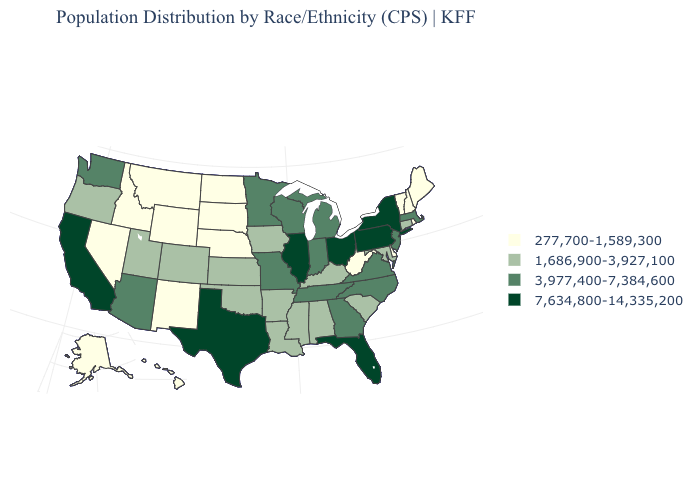What is the value of New Jersey?
Give a very brief answer. 3,977,400-7,384,600. Name the states that have a value in the range 1,686,900-3,927,100?
Answer briefly. Alabama, Arkansas, Colorado, Connecticut, Iowa, Kansas, Kentucky, Louisiana, Maryland, Mississippi, Oklahoma, Oregon, South Carolina, Utah. Does Pennsylvania have the highest value in the USA?
Give a very brief answer. Yes. Name the states that have a value in the range 3,977,400-7,384,600?
Be succinct. Arizona, Georgia, Indiana, Massachusetts, Michigan, Minnesota, Missouri, New Jersey, North Carolina, Tennessee, Virginia, Washington, Wisconsin. Does the first symbol in the legend represent the smallest category?
Write a very short answer. Yes. Does the map have missing data?
Quick response, please. No. How many symbols are there in the legend?
Give a very brief answer. 4. Name the states that have a value in the range 7,634,800-14,335,200?
Concise answer only. California, Florida, Illinois, New York, Ohio, Pennsylvania, Texas. Name the states that have a value in the range 7,634,800-14,335,200?
Quick response, please. California, Florida, Illinois, New York, Ohio, Pennsylvania, Texas. What is the value of Iowa?
Quick response, please. 1,686,900-3,927,100. Does New Mexico have the same value as Washington?
Concise answer only. No. Is the legend a continuous bar?
Keep it brief. No. What is the value of Kentucky?
Give a very brief answer. 1,686,900-3,927,100. Among the states that border Delaware , does New Jersey have the lowest value?
Write a very short answer. No. What is the highest value in the MidWest ?
Quick response, please. 7,634,800-14,335,200. 